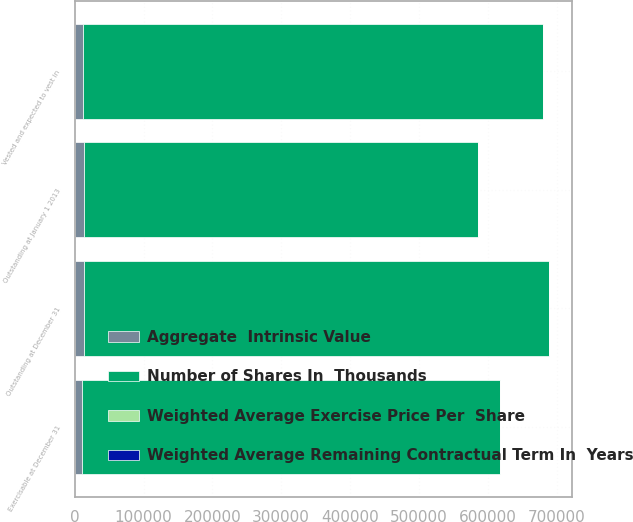Convert chart. <chart><loc_0><loc_0><loc_500><loc_500><stacked_bar_chart><ecel><fcel>Outstanding at January 1 2013<fcel>Outstanding at December 31<fcel>Vested and expected to vest in<fcel>Exercisable at December 31<nl><fcel>Aggregate  Intrinsic Value<fcel>14000<fcel>12973<fcel>12639<fcel>10401<nl><fcel>Weighted Average Remaining Contractual Term In  Years<fcel>12.12<fcel>15.7<fcel>14.89<fcel>9.38<nl><fcel>Weighted Average Exercise Price Per  Share<fcel>4.1<fcel>3.7<fcel>3.6<fcel>2.7<nl><fcel>Number of Shares In  Thousands<fcel>572530<fcel>675595<fcel>668379<fcel>607302<nl></chart> 